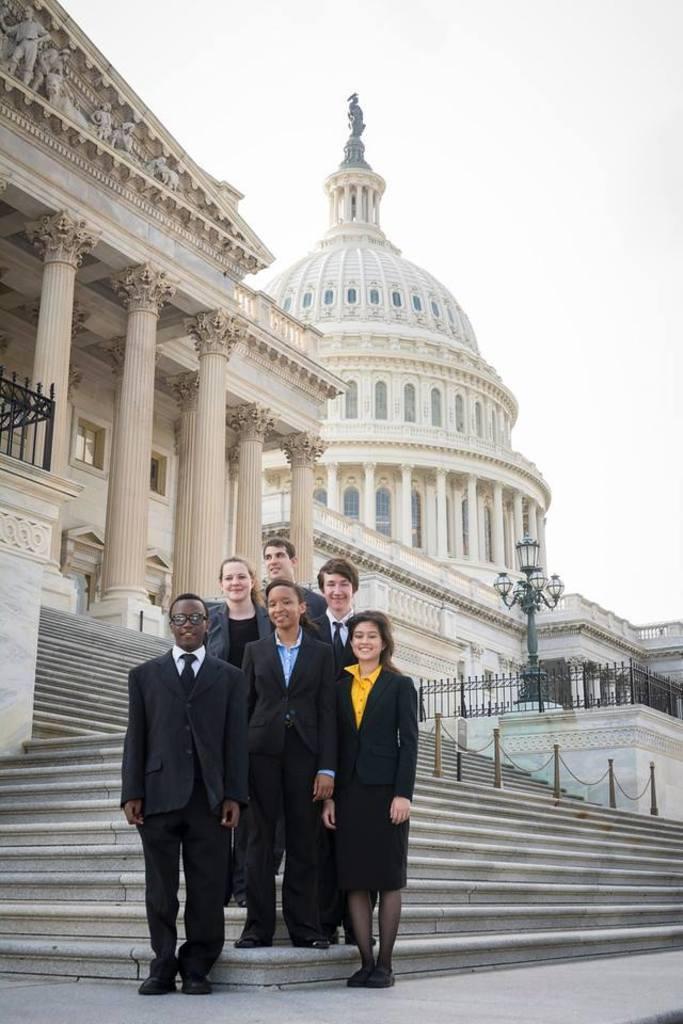How would you summarize this image in a sentence or two? In this image I can see the group of people with yellow, blue, black and white color dresses. In the background I can see the buildings, light pole, railing and the sky. 